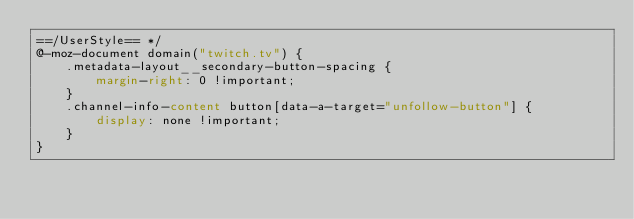Convert code to text. <code><loc_0><loc_0><loc_500><loc_500><_CSS_>==/UserStyle== */
@-moz-document domain("twitch.tv") {
    .metadata-layout__secondary-button-spacing {
        margin-right: 0 !important;
    }
    .channel-info-content button[data-a-target="unfollow-button"] {
        display: none !important;
    }
}
</code> 